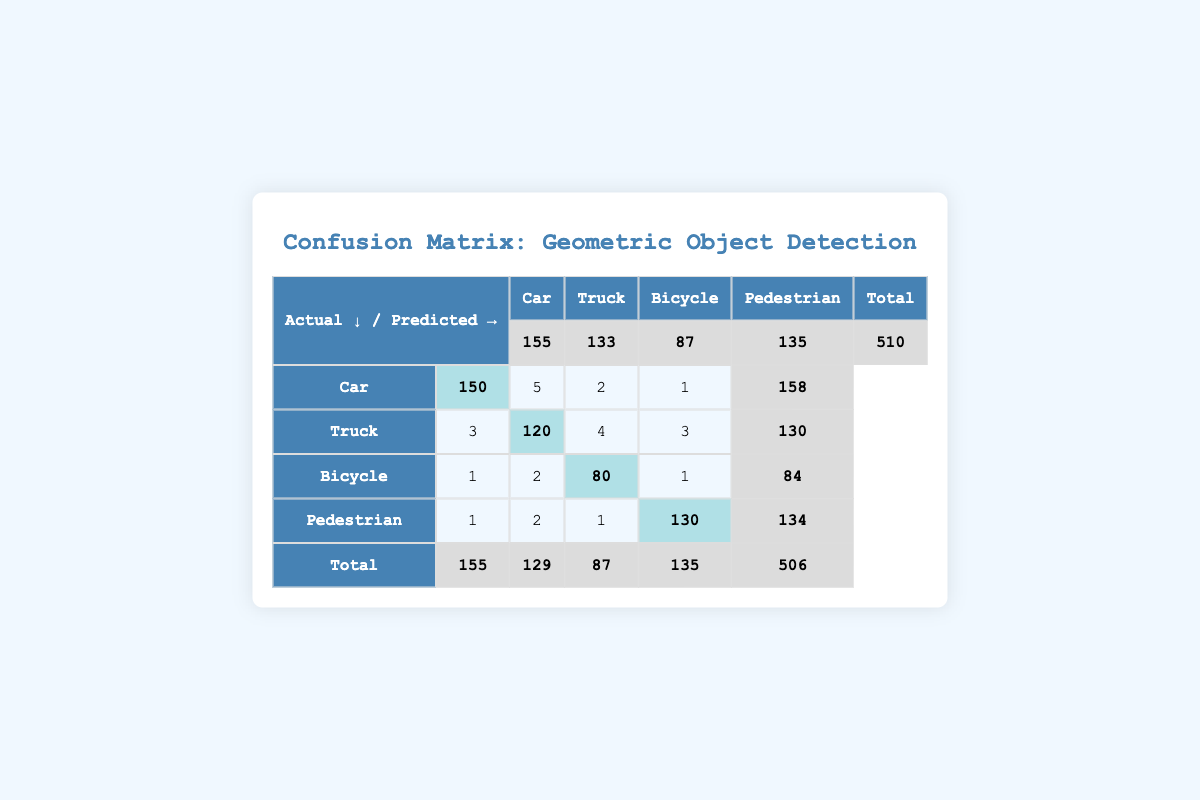What is the total number of objects detected as cars? The number of actual cars detected is 150, while 5 trucks, 2 bicycles, and 1 pedestrian were classified as cars. Summing these values, we have 150 + 5 + 2 + 1 = 158.
Answer: 158 What is the predicted count of trucks? The "predicted" row indicates that the count of trucks predicted is 133.
Answer: 133 How many bicycles were correctly classified? The correct classification of bicycles can be found in the "bicycle" row under the "bicycle" column, which shows 80.
Answer: 80 What percentage of pedestrians were correctly identified? The total number of actual pedestrians is 130. The correctly classified pedestrians are also 130. Thus, the percentage is (130/130) * 100 = 100%.
Answer: 100% Is the number of actual cars greater than the total number of incorrectly classified bicycles? There are 2 bicycles that were incorrectly classified as cars, trucks, and pedestrians combined (5 + 2 + 1 = 8). Since 150 (actual cars) > 8, the statement is true.
Answer: Yes What is the total count of incorrectly classified objects? The incorrectly classified objects are those numbers not in the highlighted main diagonal: 5 (car), 3 (truck), 1 (bicycle), 1 (pedestrian), adding to 10 (5 + 3 + 1 + 1).
Answer: 10 How many objects were actually predicted as pedestrians? The total number of actual pedestrian detections is 134, as indicated in the "Total" row under the "Pedestrian" column.
Answer: 134 What is the total number of samples in the confusion matrix? To find the total, we add all actual detections: 150 (car) + 120 (truck) + 80 (bicycle) + 130 (pedestrian) = 480.
Answer: 480 What is the difference in total counts between predicted cars and actual trucks? The predicted count of cars is 155, while the actual count of trucks is 120. Thus, the difference is 155 - 120 = 35.
Answer: 35 